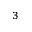<formula> <loc_0><loc_0><loc_500><loc_500>_ { 3 }</formula> 